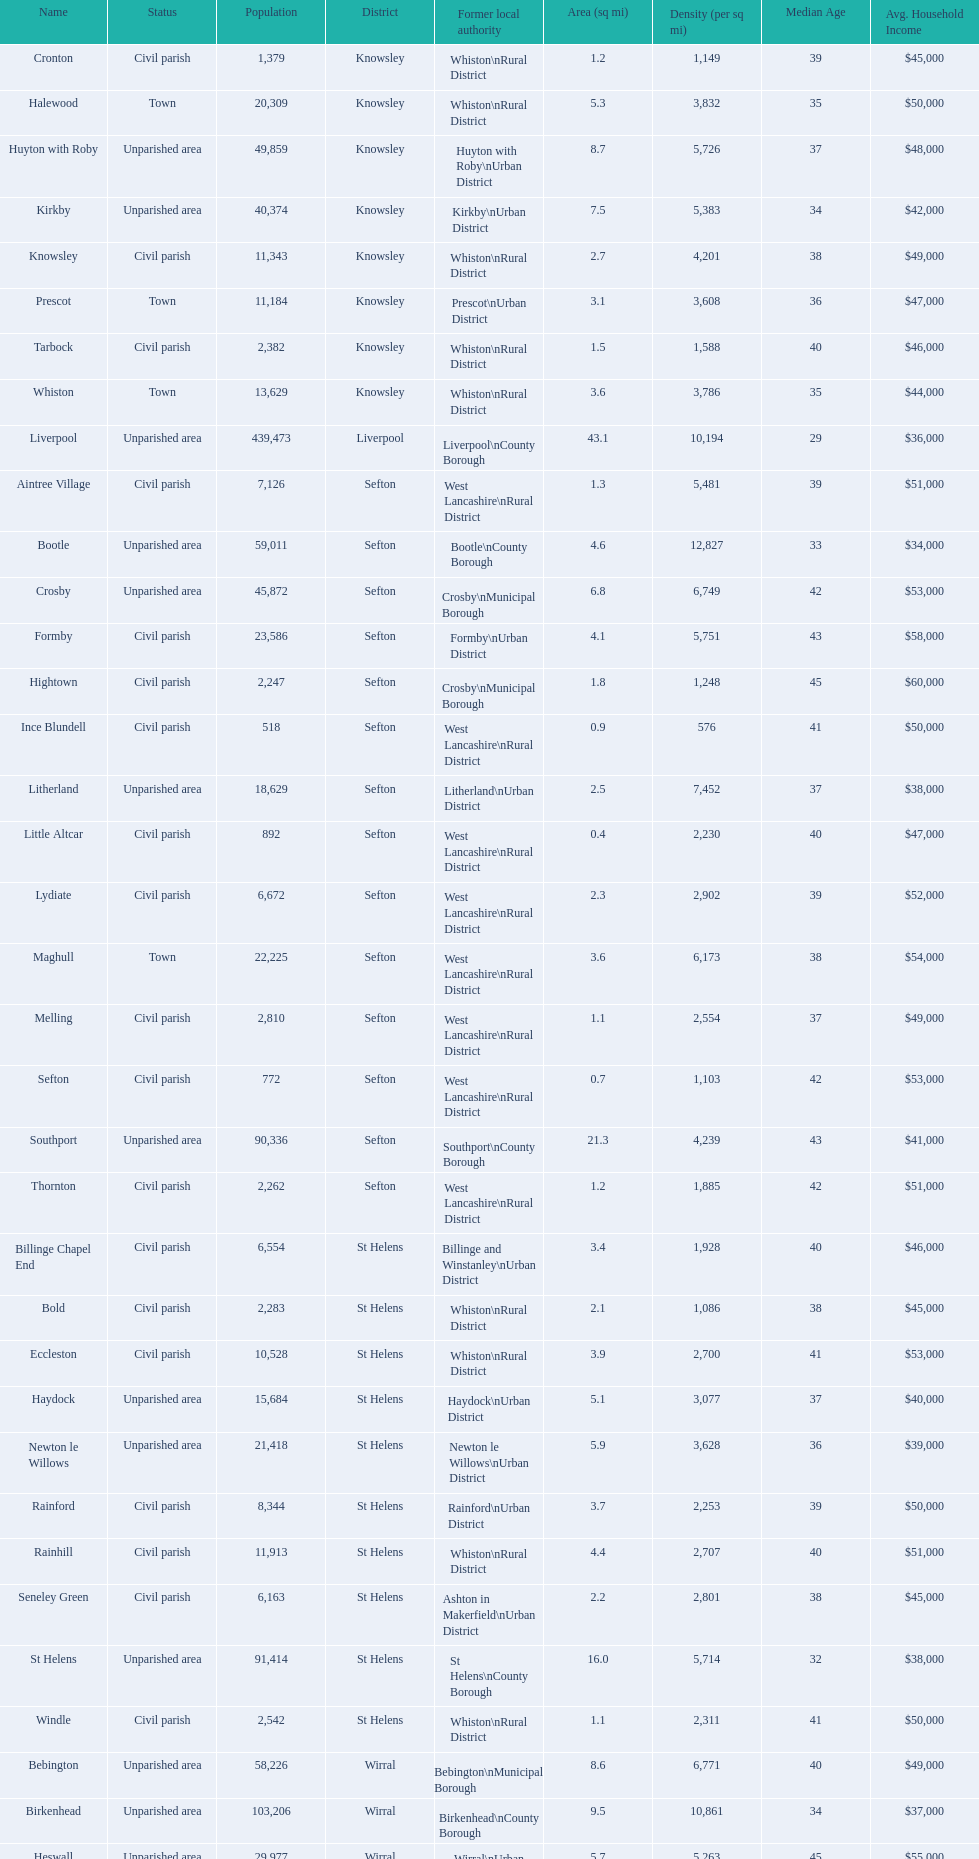Give me the full table as a dictionary. {'header': ['Name', 'Status', 'Population', 'District', 'Former local authority', 'Area (sq mi)', 'Density (per sq mi)', 'Median Age', 'Avg. Household Income'], 'rows': [['Cronton', 'Civil parish', '1,379', 'Knowsley', 'Whiston\\nRural District', '1.2', '1,149', '39', '$45,000'], ['Halewood', 'Town', '20,309', 'Knowsley', 'Whiston\\nRural District', '5.3', '3,832', '35', '$50,000'], ['Huyton with Roby', 'Unparished area', '49,859', 'Knowsley', 'Huyton with Roby\\nUrban District', '8.7', '5,726', '37', '$48,000'], ['Kirkby', 'Unparished area', '40,374', 'Knowsley', 'Kirkby\\nUrban District', '7.5', '5,383', '34', '$42,000'], ['Knowsley', 'Civil parish', '11,343', 'Knowsley', 'Whiston\\nRural District', '2.7', '4,201', '38', '$49,000'], ['Prescot', 'Town', '11,184', 'Knowsley', 'Prescot\\nUrban District', '3.1', '3,608', '36', '$47,000'], ['Tarbock', 'Civil parish', '2,382', 'Knowsley', 'Whiston\\nRural District', '1.5', '1,588', '40', '$46,000'], ['Whiston', 'Town', '13,629', 'Knowsley', 'Whiston\\nRural District', '3.6', '3,786', '35', '$44,000'], ['Liverpool', 'Unparished area', '439,473', 'Liverpool', 'Liverpool\\nCounty Borough', '43.1', '10,194', '29', '$36,000'], ['Aintree Village', 'Civil parish', '7,126', 'Sefton', 'West Lancashire\\nRural District', '1.3', '5,481', '39', '$51,000'], ['Bootle', 'Unparished area', '59,011', 'Sefton', 'Bootle\\nCounty Borough', '4.6', '12,827', '33', '$34,000'], ['Crosby', 'Unparished area', '45,872', 'Sefton', 'Crosby\\nMunicipal Borough', '6.8', '6,749', '42', '$53,000'], ['Formby', 'Civil parish', '23,586', 'Sefton', 'Formby\\nUrban District', '4.1', '5,751', '43', '$58,000'], ['Hightown', 'Civil parish', '2,247', 'Sefton', 'Crosby\\nMunicipal Borough', '1.8', '1,248', '45', '$60,000'], ['Ince Blundell', 'Civil parish', '518', 'Sefton', 'West Lancashire\\nRural District', '0.9', '576', '41', '$50,000'], ['Litherland', 'Unparished area', '18,629', 'Sefton', 'Litherland\\nUrban District', '2.5', '7,452', '37', '$38,000'], ['Little Altcar', 'Civil parish', '892', 'Sefton', 'West Lancashire\\nRural District', '0.4', '2,230', '40', '$47,000'], ['Lydiate', 'Civil parish', '6,672', 'Sefton', 'West Lancashire\\nRural District', '2.3', '2,902', '39', '$52,000'], ['Maghull', 'Town', '22,225', 'Sefton', 'West Lancashire\\nRural District', '3.6', '6,173', '38', '$54,000'], ['Melling', 'Civil parish', '2,810', 'Sefton', 'West Lancashire\\nRural District', '1.1', '2,554', '37', '$49,000'], ['Sefton', 'Civil parish', '772', 'Sefton', 'West Lancashire\\nRural District', '0.7', '1,103', '42', '$53,000'], ['Southport', 'Unparished area', '90,336', 'Sefton', 'Southport\\nCounty Borough', '21.3', '4,239', '43', '$41,000'], ['Thornton', 'Civil parish', '2,262', 'Sefton', 'West Lancashire\\nRural District', '1.2', '1,885', '42', '$51,000'], ['Billinge Chapel End', 'Civil parish', '6,554', 'St Helens', 'Billinge and Winstanley\\nUrban District', '3.4', '1,928', '40', '$46,000'], ['Bold', 'Civil parish', '2,283', 'St Helens', 'Whiston\\nRural District', '2.1', '1,086', '38', '$45,000'], ['Eccleston', 'Civil parish', '10,528', 'St Helens', 'Whiston\\nRural District', '3.9', '2,700', '41', '$53,000'], ['Haydock', 'Unparished area', '15,684', 'St Helens', 'Haydock\\nUrban District', '5.1', '3,077', '37', '$40,000'], ['Newton le Willows', 'Unparished area', '21,418', 'St Helens', 'Newton le Willows\\nUrban District', '5.9', '3,628', '36', '$39,000'], ['Rainford', 'Civil parish', '8,344', 'St Helens', 'Rainford\\nUrban District', '3.7', '2,253', '39', '$50,000'], ['Rainhill', 'Civil parish', '11,913', 'St Helens', 'Whiston\\nRural District', '4.4', '2,707', '40', '$51,000'], ['Seneley Green', 'Civil parish', '6,163', 'St Helens', 'Ashton in Makerfield\\nUrban District', '2.2', '2,801', '38', '$45,000'], ['St Helens', 'Unparished area', '91,414', 'St Helens', 'St Helens\\nCounty Borough', '16.0', '5,714', '32', '$38,000'], ['Windle', 'Civil parish', '2,542', 'St Helens', 'Whiston\\nRural District', '1.1', '2,311', '41', '$50,000'], ['Bebington', 'Unparished area', '58,226', 'Wirral', 'Bebington\\nMunicipal Borough', '8.6', '6,771', '40', '$49,000'], ['Birkenhead', 'Unparished area', '103,206', 'Wirral', 'Birkenhead\\nCounty Borough', '9.5', '10,861', '34', '$37,000'], ['Heswall', 'Unparished area', '29,977', 'Wirral', 'Wirral\\nUrban District', '5.7', '5,263', '45', '$55,000'], ['Hoylake', 'Unparished area', '35,655', 'Wirral', 'Hoylake\\nUrban District', '10.3', '3,461', '39', '$50,000'], ['Wallasey', 'Unparished area', '84,348', 'Wirral', 'Wallasey\\nCounty Borough', '14.6', '5,774', '38', '$43,000']]} How many areas are unparished areas? 15. 